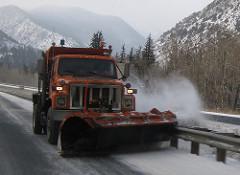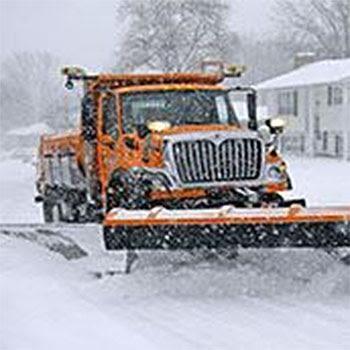The first image is the image on the left, the second image is the image on the right. For the images shown, is this caption "One snow plow is parked in a non-snow covered parking lot." true? Answer yes or no. No. The first image is the image on the left, the second image is the image on the right. Examine the images to the left and right. Is the description "The left and right image contains the same number of orange snow trucks." accurate? Answer yes or no. Yes. 